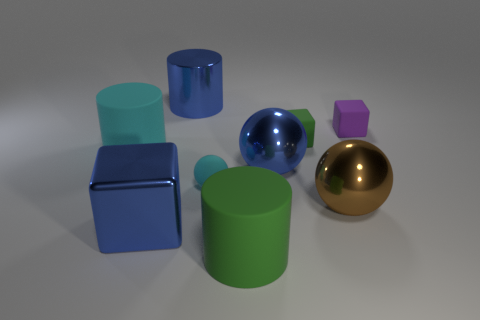Subtract all large cyan matte cylinders. How many cylinders are left? 2 Subtract all cylinders. How many objects are left? 6 Add 1 small cyan metallic cylinders. How many objects exist? 10 Subtract all large cylinders. Subtract all large green matte objects. How many objects are left? 5 Add 8 cyan cylinders. How many cyan cylinders are left? 9 Add 2 small blocks. How many small blocks exist? 4 Subtract 0 brown blocks. How many objects are left? 9 Subtract 2 balls. How many balls are left? 1 Subtract all brown blocks. Subtract all yellow cylinders. How many blocks are left? 3 Subtract all red blocks. How many green balls are left? 0 